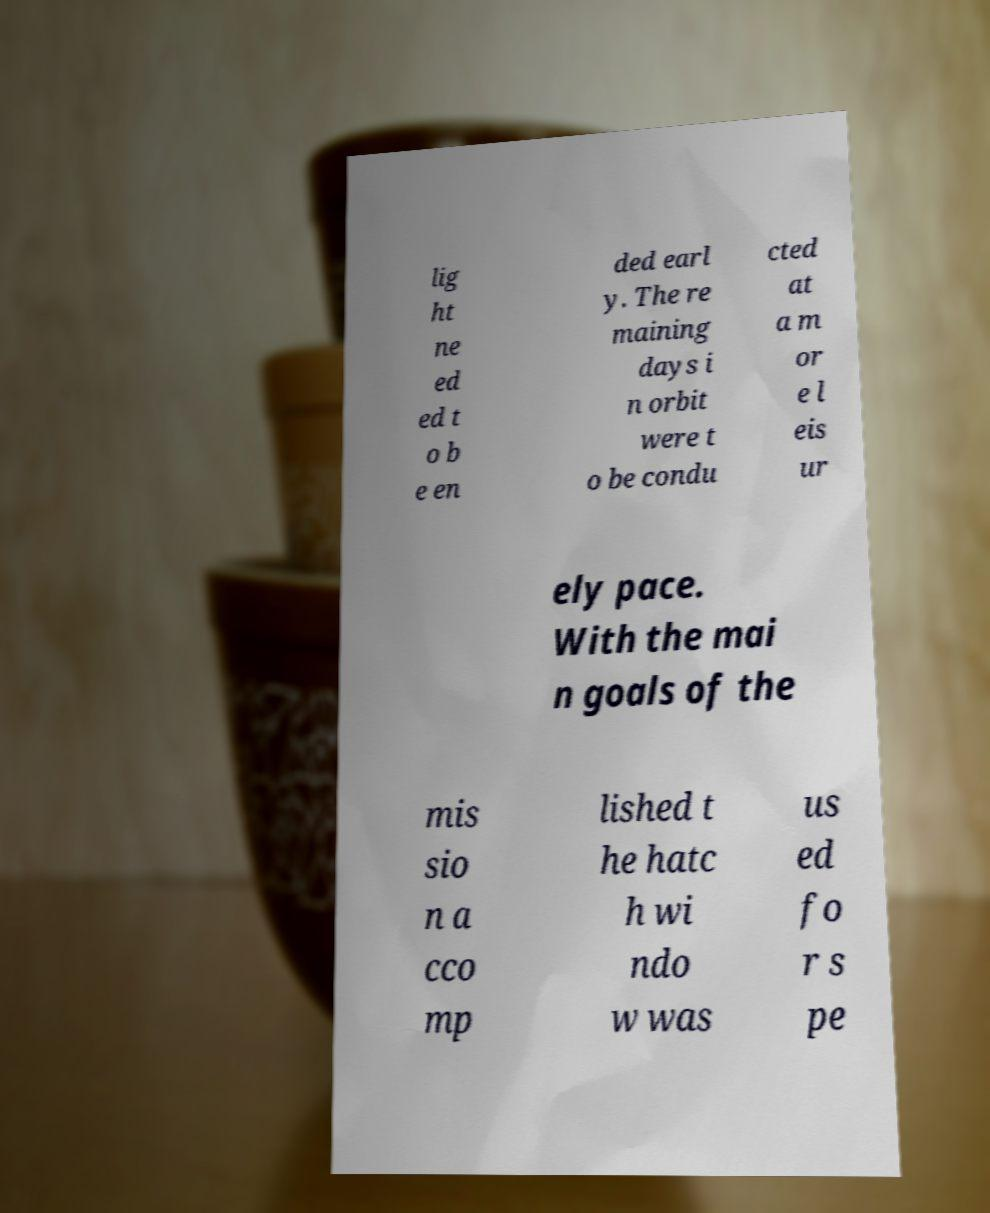Please read and relay the text visible in this image. What does it say? lig ht ne ed ed t o b e en ded earl y. The re maining days i n orbit were t o be condu cted at a m or e l eis ur ely pace. With the mai n goals of the mis sio n a cco mp lished t he hatc h wi ndo w was us ed fo r s pe 